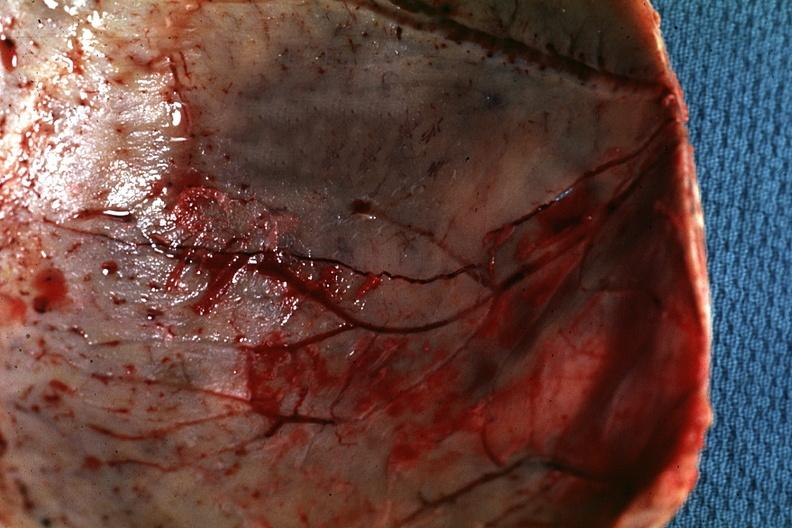what does this image show?
Answer the question using a single word or phrase. Fracture line well shown very thin skull eggshell type 